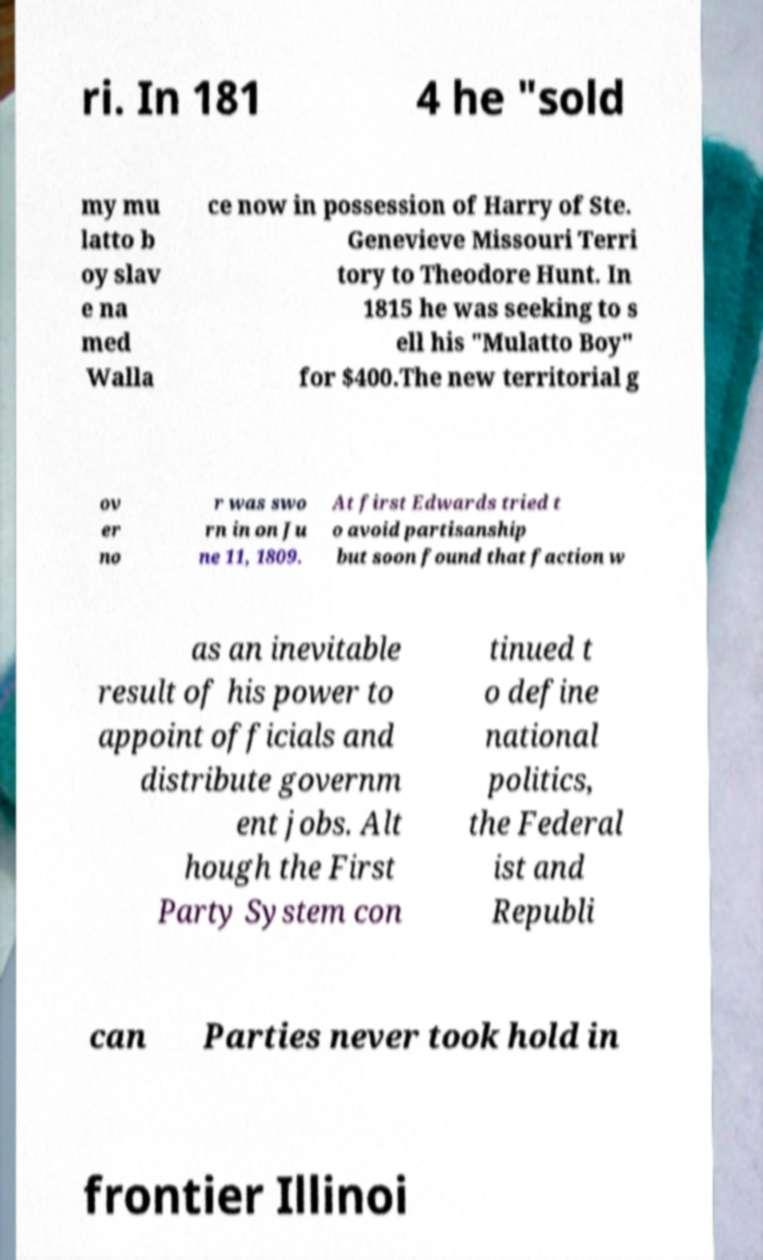Can you read and provide the text displayed in the image?This photo seems to have some interesting text. Can you extract and type it out for me? ri. In 181 4 he "sold my mu latto b oy slav e na med Walla ce now in possession of Harry of Ste. Genevieve Missouri Terri tory to Theodore Hunt. In 1815 he was seeking to s ell his "Mulatto Boy" for $400.The new territorial g ov er no r was swo rn in on Ju ne 11, 1809. At first Edwards tried t o avoid partisanship but soon found that faction w as an inevitable result of his power to appoint officials and distribute governm ent jobs. Alt hough the First Party System con tinued t o define national politics, the Federal ist and Republi can Parties never took hold in frontier Illinoi 